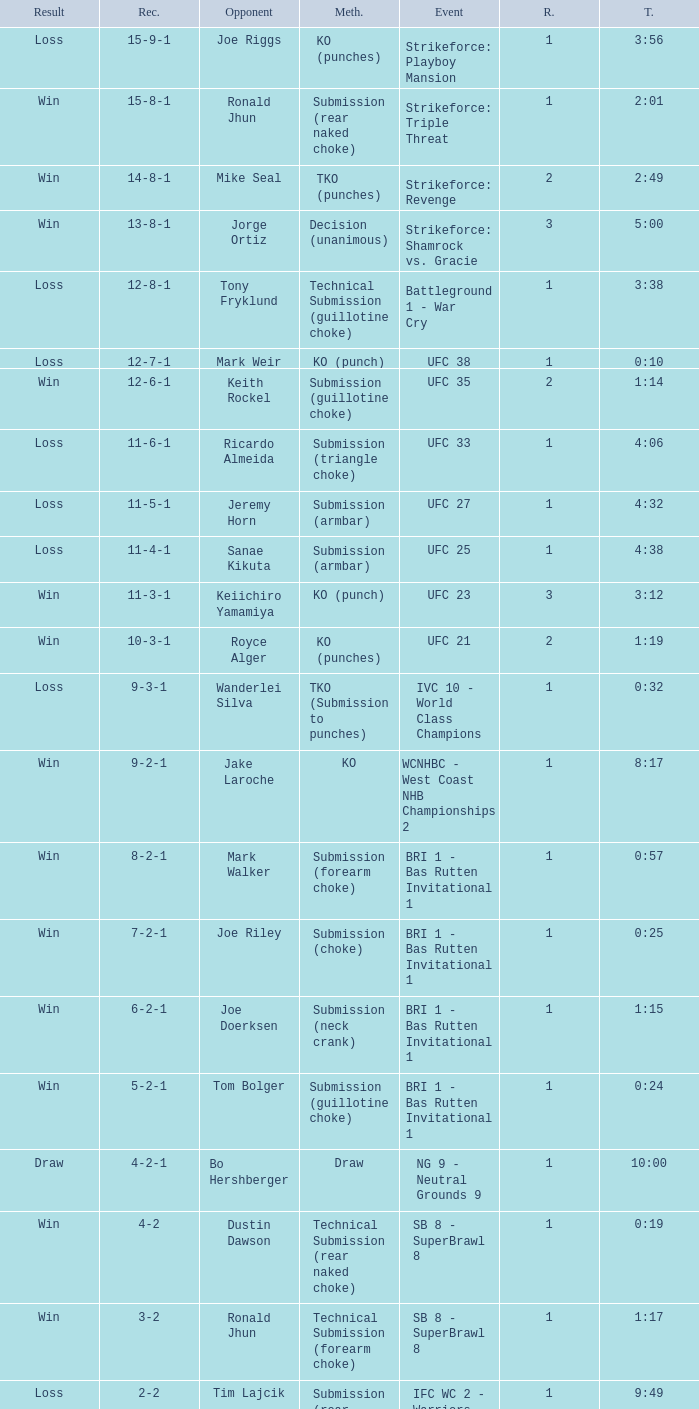What was the outcome when the fight involved keith rockel? 12-6-1. 